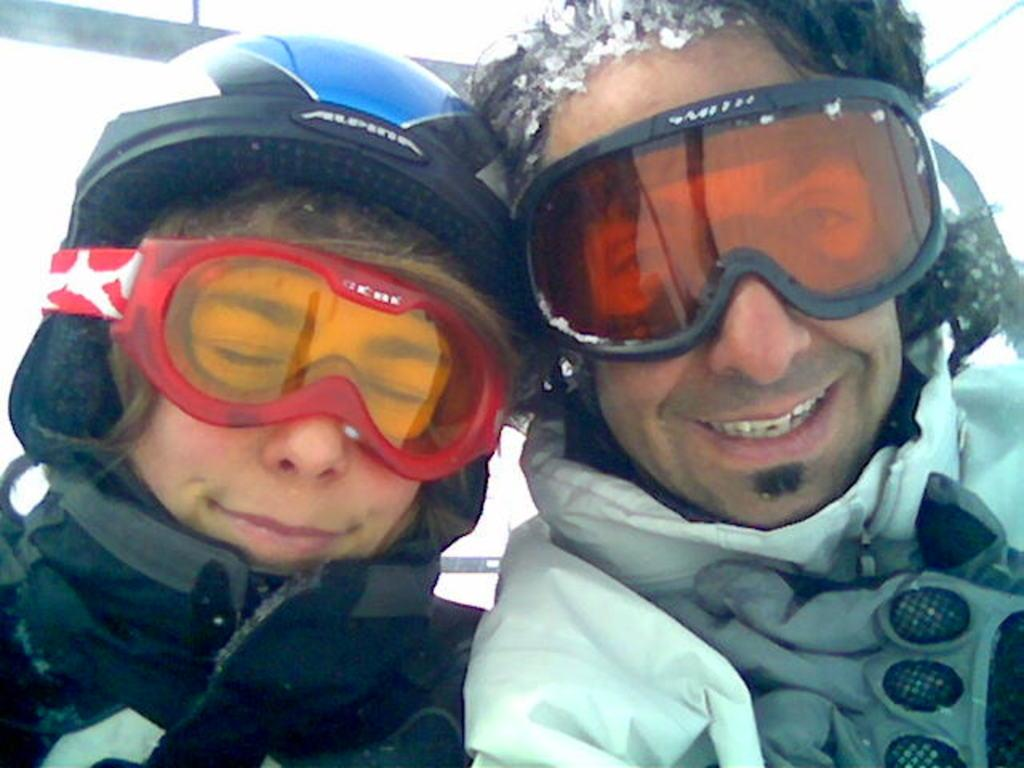What is the main subject of the image? The main subject of the image is the persons in the center of the image. What type of clothing are the persons wearing? The persons are wearing winter clothes. What expression do the persons have on their faces? The persons have smiles on their faces. What type of apples can be seen in the office in the image? There is no mention of apples or an office in the image; it features persons wearing winter clothes and smiling. 